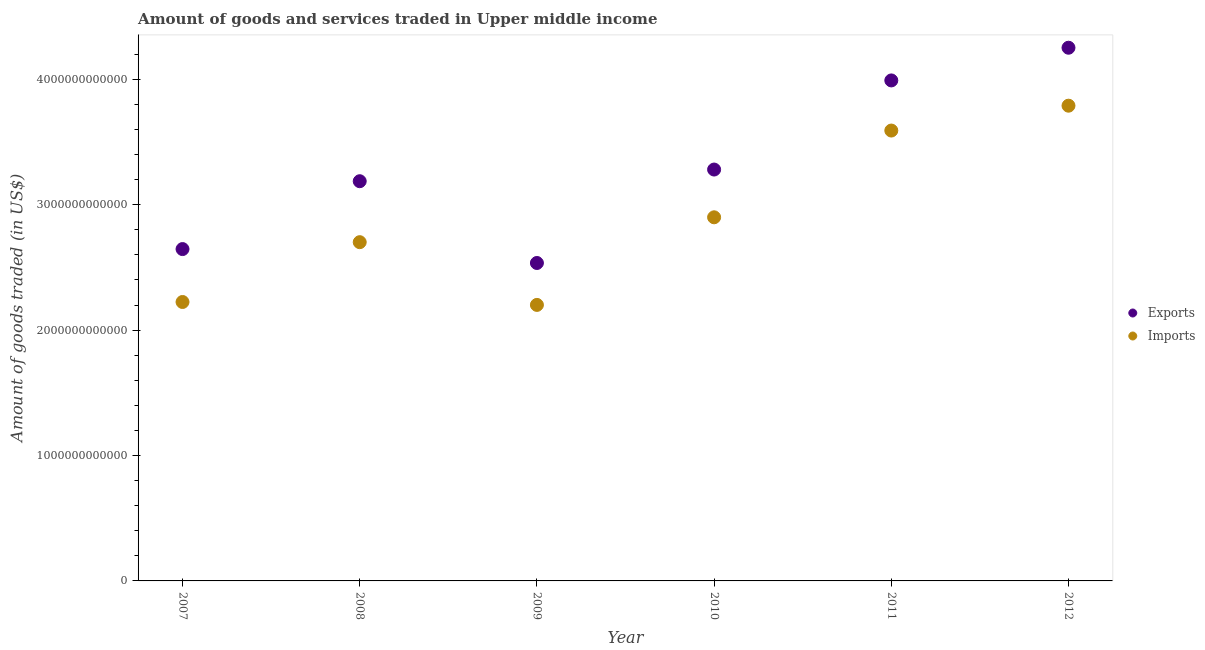Is the number of dotlines equal to the number of legend labels?
Provide a succinct answer. Yes. What is the amount of goods imported in 2007?
Offer a very short reply. 2.22e+12. Across all years, what is the maximum amount of goods imported?
Offer a terse response. 3.79e+12. Across all years, what is the minimum amount of goods exported?
Provide a short and direct response. 2.54e+12. In which year was the amount of goods imported minimum?
Make the answer very short. 2009. What is the total amount of goods imported in the graph?
Make the answer very short. 1.74e+13. What is the difference between the amount of goods imported in 2007 and that in 2011?
Ensure brevity in your answer.  -1.37e+12. What is the difference between the amount of goods exported in 2010 and the amount of goods imported in 2012?
Give a very brief answer. -5.09e+11. What is the average amount of goods exported per year?
Your answer should be compact. 3.32e+12. In the year 2007, what is the difference between the amount of goods exported and amount of goods imported?
Give a very brief answer. 4.22e+11. In how many years, is the amount of goods imported greater than 3600000000000 US$?
Your answer should be compact. 1. What is the ratio of the amount of goods exported in 2009 to that in 2010?
Make the answer very short. 0.77. What is the difference between the highest and the second highest amount of goods exported?
Your answer should be very brief. 2.61e+11. What is the difference between the highest and the lowest amount of goods imported?
Your response must be concise. 1.59e+12. In how many years, is the amount of goods exported greater than the average amount of goods exported taken over all years?
Provide a short and direct response. 2. Is the amount of goods imported strictly greater than the amount of goods exported over the years?
Your response must be concise. No. How many years are there in the graph?
Make the answer very short. 6. What is the difference between two consecutive major ticks on the Y-axis?
Your answer should be compact. 1.00e+12. Does the graph contain any zero values?
Provide a succinct answer. No. Does the graph contain grids?
Give a very brief answer. No. Where does the legend appear in the graph?
Make the answer very short. Center right. How many legend labels are there?
Offer a very short reply. 2. How are the legend labels stacked?
Keep it short and to the point. Vertical. What is the title of the graph?
Your response must be concise. Amount of goods and services traded in Upper middle income. What is the label or title of the Y-axis?
Make the answer very short. Amount of goods traded (in US$). What is the Amount of goods traded (in US$) of Exports in 2007?
Keep it short and to the point. 2.65e+12. What is the Amount of goods traded (in US$) in Imports in 2007?
Keep it short and to the point. 2.22e+12. What is the Amount of goods traded (in US$) of Exports in 2008?
Your answer should be compact. 3.19e+12. What is the Amount of goods traded (in US$) in Imports in 2008?
Provide a short and direct response. 2.70e+12. What is the Amount of goods traded (in US$) in Exports in 2009?
Offer a very short reply. 2.54e+12. What is the Amount of goods traded (in US$) of Imports in 2009?
Provide a succinct answer. 2.20e+12. What is the Amount of goods traded (in US$) of Exports in 2010?
Your answer should be compact. 3.28e+12. What is the Amount of goods traded (in US$) of Imports in 2010?
Your answer should be compact. 2.90e+12. What is the Amount of goods traded (in US$) in Exports in 2011?
Your response must be concise. 3.99e+12. What is the Amount of goods traded (in US$) in Imports in 2011?
Give a very brief answer. 3.59e+12. What is the Amount of goods traded (in US$) of Exports in 2012?
Provide a succinct answer. 4.25e+12. What is the Amount of goods traded (in US$) in Imports in 2012?
Provide a short and direct response. 3.79e+12. Across all years, what is the maximum Amount of goods traded (in US$) in Exports?
Offer a very short reply. 4.25e+12. Across all years, what is the maximum Amount of goods traded (in US$) in Imports?
Provide a succinct answer. 3.79e+12. Across all years, what is the minimum Amount of goods traded (in US$) of Exports?
Provide a succinct answer. 2.54e+12. Across all years, what is the minimum Amount of goods traded (in US$) in Imports?
Provide a short and direct response. 2.20e+12. What is the total Amount of goods traded (in US$) of Exports in the graph?
Your response must be concise. 1.99e+13. What is the total Amount of goods traded (in US$) in Imports in the graph?
Your response must be concise. 1.74e+13. What is the difference between the Amount of goods traded (in US$) of Exports in 2007 and that in 2008?
Your response must be concise. -5.41e+11. What is the difference between the Amount of goods traded (in US$) in Imports in 2007 and that in 2008?
Offer a very short reply. -4.77e+11. What is the difference between the Amount of goods traded (in US$) in Exports in 2007 and that in 2009?
Your response must be concise. 1.11e+11. What is the difference between the Amount of goods traded (in US$) in Imports in 2007 and that in 2009?
Your answer should be very brief. 2.32e+1. What is the difference between the Amount of goods traded (in US$) in Exports in 2007 and that in 2010?
Keep it short and to the point. -6.34e+11. What is the difference between the Amount of goods traded (in US$) of Imports in 2007 and that in 2010?
Provide a short and direct response. -6.75e+11. What is the difference between the Amount of goods traded (in US$) in Exports in 2007 and that in 2011?
Give a very brief answer. -1.34e+12. What is the difference between the Amount of goods traded (in US$) in Imports in 2007 and that in 2011?
Give a very brief answer. -1.37e+12. What is the difference between the Amount of goods traded (in US$) of Exports in 2007 and that in 2012?
Provide a short and direct response. -1.61e+12. What is the difference between the Amount of goods traded (in US$) of Imports in 2007 and that in 2012?
Your answer should be very brief. -1.57e+12. What is the difference between the Amount of goods traded (in US$) in Exports in 2008 and that in 2009?
Provide a short and direct response. 6.52e+11. What is the difference between the Amount of goods traded (in US$) in Imports in 2008 and that in 2009?
Offer a terse response. 5.00e+11. What is the difference between the Amount of goods traded (in US$) of Exports in 2008 and that in 2010?
Ensure brevity in your answer.  -9.30e+1. What is the difference between the Amount of goods traded (in US$) in Imports in 2008 and that in 2010?
Offer a very short reply. -1.98e+11. What is the difference between the Amount of goods traded (in US$) of Exports in 2008 and that in 2011?
Offer a terse response. -8.04e+11. What is the difference between the Amount of goods traded (in US$) of Imports in 2008 and that in 2011?
Keep it short and to the point. -8.90e+11. What is the difference between the Amount of goods traded (in US$) of Exports in 2008 and that in 2012?
Give a very brief answer. -1.06e+12. What is the difference between the Amount of goods traded (in US$) of Imports in 2008 and that in 2012?
Your answer should be very brief. -1.09e+12. What is the difference between the Amount of goods traded (in US$) of Exports in 2009 and that in 2010?
Keep it short and to the point. -7.45e+11. What is the difference between the Amount of goods traded (in US$) of Imports in 2009 and that in 2010?
Make the answer very short. -6.99e+11. What is the difference between the Amount of goods traded (in US$) of Exports in 2009 and that in 2011?
Provide a short and direct response. -1.46e+12. What is the difference between the Amount of goods traded (in US$) in Imports in 2009 and that in 2011?
Provide a short and direct response. -1.39e+12. What is the difference between the Amount of goods traded (in US$) in Exports in 2009 and that in 2012?
Your answer should be compact. -1.72e+12. What is the difference between the Amount of goods traded (in US$) in Imports in 2009 and that in 2012?
Make the answer very short. -1.59e+12. What is the difference between the Amount of goods traded (in US$) of Exports in 2010 and that in 2011?
Keep it short and to the point. -7.11e+11. What is the difference between the Amount of goods traded (in US$) of Imports in 2010 and that in 2011?
Offer a terse response. -6.92e+11. What is the difference between the Amount of goods traded (in US$) in Exports in 2010 and that in 2012?
Ensure brevity in your answer.  -9.71e+11. What is the difference between the Amount of goods traded (in US$) in Imports in 2010 and that in 2012?
Your answer should be compact. -8.90e+11. What is the difference between the Amount of goods traded (in US$) in Exports in 2011 and that in 2012?
Your answer should be very brief. -2.61e+11. What is the difference between the Amount of goods traded (in US$) in Imports in 2011 and that in 2012?
Offer a terse response. -1.98e+11. What is the difference between the Amount of goods traded (in US$) in Exports in 2007 and the Amount of goods traded (in US$) in Imports in 2008?
Your response must be concise. -5.50e+1. What is the difference between the Amount of goods traded (in US$) in Exports in 2007 and the Amount of goods traded (in US$) in Imports in 2009?
Offer a terse response. 4.45e+11. What is the difference between the Amount of goods traded (in US$) in Exports in 2007 and the Amount of goods traded (in US$) in Imports in 2010?
Make the answer very short. -2.53e+11. What is the difference between the Amount of goods traded (in US$) in Exports in 2007 and the Amount of goods traded (in US$) in Imports in 2011?
Keep it short and to the point. -9.45e+11. What is the difference between the Amount of goods traded (in US$) of Exports in 2007 and the Amount of goods traded (in US$) of Imports in 2012?
Your response must be concise. -1.14e+12. What is the difference between the Amount of goods traded (in US$) in Exports in 2008 and the Amount of goods traded (in US$) in Imports in 2009?
Offer a terse response. 9.86e+11. What is the difference between the Amount of goods traded (in US$) of Exports in 2008 and the Amount of goods traded (in US$) of Imports in 2010?
Provide a succinct answer. 2.88e+11. What is the difference between the Amount of goods traded (in US$) of Exports in 2008 and the Amount of goods traded (in US$) of Imports in 2011?
Provide a short and direct response. -4.04e+11. What is the difference between the Amount of goods traded (in US$) of Exports in 2008 and the Amount of goods traded (in US$) of Imports in 2012?
Make the answer very short. -6.02e+11. What is the difference between the Amount of goods traded (in US$) in Exports in 2009 and the Amount of goods traded (in US$) in Imports in 2010?
Your answer should be very brief. -3.64e+11. What is the difference between the Amount of goods traded (in US$) of Exports in 2009 and the Amount of goods traded (in US$) of Imports in 2011?
Your answer should be compact. -1.06e+12. What is the difference between the Amount of goods traded (in US$) in Exports in 2009 and the Amount of goods traded (in US$) in Imports in 2012?
Provide a succinct answer. -1.25e+12. What is the difference between the Amount of goods traded (in US$) of Exports in 2010 and the Amount of goods traded (in US$) of Imports in 2011?
Offer a very short reply. -3.11e+11. What is the difference between the Amount of goods traded (in US$) of Exports in 2010 and the Amount of goods traded (in US$) of Imports in 2012?
Offer a very short reply. -5.09e+11. What is the difference between the Amount of goods traded (in US$) in Exports in 2011 and the Amount of goods traded (in US$) in Imports in 2012?
Ensure brevity in your answer.  2.01e+11. What is the average Amount of goods traded (in US$) in Exports per year?
Offer a terse response. 3.32e+12. What is the average Amount of goods traded (in US$) of Imports per year?
Ensure brevity in your answer.  2.90e+12. In the year 2007, what is the difference between the Amount of goods traded (in US$) in Exports and Amount of goods traded (in US$) in Imports?
Your response must be concise. 4.22e+11. In the year 2008, what is the difference between the Amount of goods traded (in US$) of Exports and Amount of goods traded (in US$) of Imports?
Provide a short and direct response. 4.86e+11. In the year 2009, what is the difference between the Amount of goods traded (in US$) of Exports and Amount of goods traded (in US$) of Imports?
Offer a very short reply. 3.34e+11. In the year 2010, what is the difference between the Amount of goods traded (in US$) in Exports and Amount of goods traded (in US$) in Imports?
Make the answer very short. 3.81e+11. In the year 2011, what is the difference between the Amount of goods traded (in US$) of Exports and Amount of goods traded (in US$) of Imports?
Provide a short and direct response. 4.00e+11. In the year 2012, what is the difference between the Amount of goods traded (in US$) in Exports and Amount of goods traded (in US$) in Imports?
Keep it short and to the point. 4.62e+11. What is the ratio of the Amount of goods traded (in US$) in Exports in 2007 to that in 2008?
Ensure brevity in your answer.  0.83. What is the ratio of the Amount of goods traded (in US$) in Imports in 2007 to that in 2008?
Your response must be concise. 0.82. What is the ratio of the Amount of goods traded (in US$) in Exports in 2007 to that in 2009?
Give a very brief answer. 1.04. What is the ratio of the Amount of goods traded (in US$) in Imports in 2007 to that in 2009?
Provide a succinct answer. 1.01. What is the ratio of the Amount of goods traded (in US$) of Exports in 2007 to that in 2010?
Ensure brevity in your answer.  0.81. What is the ratio of the Amount of goods traded (in US$) in Imports in 2007 to that in 2010?
Offer a terse response. 0.77. What is the ratio of the Amount of goods traded (in US$) in Exports in 2007 to that in 2011?
Provide a short and direct response. 0.66. What is the ratio of the Amount of goods traded (in US$) in Imports in 2007 to that in 2011?
Keep it short and to the point. 0.62. What is the ratio of the Amount of goods traded (in US$) in Exports in 2007 to that in 2012?
Provide a short and direct response. 0.62. What is the ratio of the Amount of goods traded (in US$) of Imports in 2007 to that in 2012?
Make the answer very short. 0.59. What is the ratio of the Amount of goods traded (in US$) of Exports in 2008 to that in 2009?
Your response must be concise. 1.26. What is the ratio of the Amount of goods traded (in US$) in Imports in 2008 to that in 2009?
Your answer should be compact. 1.23. What is the ratio of the Amount of goods traded (in US$) of Exports in 2008 to that in 2010?
Keep it short and to the point. 0.97. What is the ratio of the Amount of goods traded (in US$) of Imports in 2008 to that in 2010?
Provide a short and direct response. 0.93. What is the ratio of the Amount of goods traded (in US$) in Exports in 2008 to that in 2011?
Give a very brief answer. 0.8. What is the ratio of the Amount of goods traded (in US$) of Imports in 2008 to that in 2011?
Your response must be concise. 0.75. What is the ratio of the Amount of goods traded (in US$) in Exports in 2008 to that in 2012?
Offer a very short reply. 0.75. What is the ratio of the Amount of goods traded (in US$) of Imports in 2008 to that in 2012?
Your answer should be compact. 0.71. What is the ratio of the Amount of goods traded (in US$) of Exports in 2009 to that in 2010?
Make the answer very short. 0.77. What is the ratio of the Amount of goods traded (in US$) of Imports in 2009 to that in 2010?
Provide a short and direct response. 0.76. What is the ratio of the Amount of goods traded (in US$) of Exports in 2009 to that in 2011?
Keep it short and to the point. 0.64. What is the ratio of the Amount of goods traded (in US$) of Imports in 2009 to that in 2011?
Your response must be concise. 0.61. What is the ratio of the Amount of goods traded (in US$) of Exports in 2009 to that in 2012?
Keep it short and to the point. 0.6. What is the ratio of the Amount of goods traded (in US$) of Imports in 2009 to that in 2012?
Offer a very short reply. 0.58. What is the ratio of the Amount of goods traded (in US$) of Exports in 2010 to that in 2011?
Make the answer very short. 0.82. What is the ratio of the Amount of goods traded (in US$) in Imports in 2010 to that in 2011?
Provide a short and direct response. 0.81. What is the ratio of the Amount of goods traded (in US$) in Exports in 2010 to that in 2012?
Provide a short and direct response. 0.77. What is the ratio of the Amount of goods traded (in US$) of Imports in 2010 to that in 2012?
Make the answer very short. 0.77. What is the ratio of the Amount of goods traded (in US$) of Exports in 2011 to that in 2012?
Make the answer very short. 0.94. What is the ratio of the Amount of goods traded (in US$) of Imports in 2011 to that in 2012?
Offer a terse response. 0.95. What is the difference between the highest and the second highest Amount of goods traded (in US$) of Exports?
Your answer should be very brief. 2.61e+11. What is the difference between the highest and the second highest Amount of goods traded (in US$) in Imports?
Your response must be concise. 1.98e+11. What is the difference between the highest and the lowest Amount of goods traded (in US$) of Exports?
Offer a very short reply. 1.72e+12. What is the difference between the highest and the lowest Amount of goods traded (in US$) in Imports?
Keep it short and to the point. 1.59e+12. 